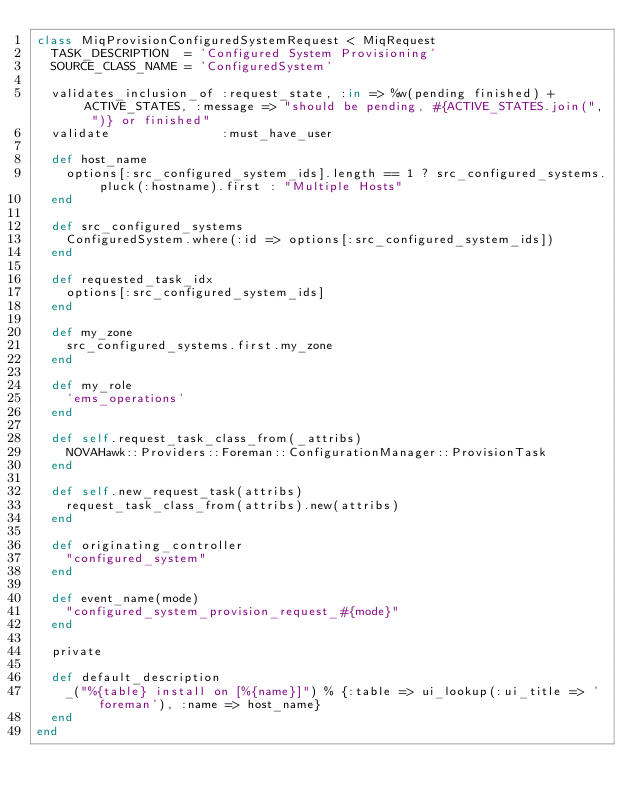<code> <loc_0><loc_0><loc_500><loc_500><_Ruby_>class MiqProvisionConfiguredSystemRequest < MiqRequest
  TASK_DESCRIPTION  = 'Configured System Provisioning'
  SOURCE_CLASS_NAME = 'ConfiguredSystem'

  validates_inclusion_of :request_state, :in => %w(pending finished) + ACTIVE_STATES, :message => "should be pending, #{ACTIVE_STATES.join(", ")} or finished"
  validate               :must_have_user

  def host_name
    options[:src_configured_system_ids].length == 1 ? src_configured_systems.pluck(:hostname).first : "Multiple Hosts"
  end

  def src_configured_systems
    ConfiguredSystem.where(:id => options[:src_configured_system_ids])
  end

  def requested_task_idx
    options[:src_configured_system_ids]
  end

  def my_zone
    src_configured_systems.first.my_zone
  end

  def my_role
    'ems_operations'
  end

  def self.request_task_class_from(_attribs)
    NOVAHawk::Providers::Foreman::ConfigurationManager::ProvisionTask
  end

  def self.new_request_task(attribs)
    request_task_class_from(attribs).new(attribs)
  end

  def originating_controller
    "configured_system"
  end

  def event_name(mode)
    "configured_system_provision_request_#{mode}"
  end

  private

  def default_description
    _("%{table} install on [%{name}]") % {:table => ui_lookup(:ui_title => 'foreman'), :name => host_name}
  end
end
</code> 